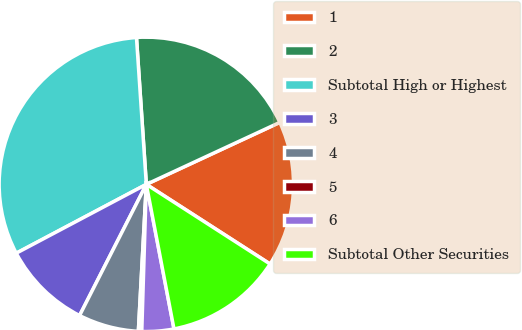Convert chart to OTSL. <chart><loc_0><loc_0><loc_500><loc_500><pie_chart><fcel>1<fcel>2<fcel>Subtotal High or Highest<fcel>3<fcel>4<fcel>5<fcel>6<fcel>Subtotal Other Securities<nl><fcel>16.02%<fcel>19.15%<fcel>31.68%<fcel>9.76%<fcel>6.63%<fcel>0.37%<fcel>3.5%<fcel>12.89%<nl></chart> 